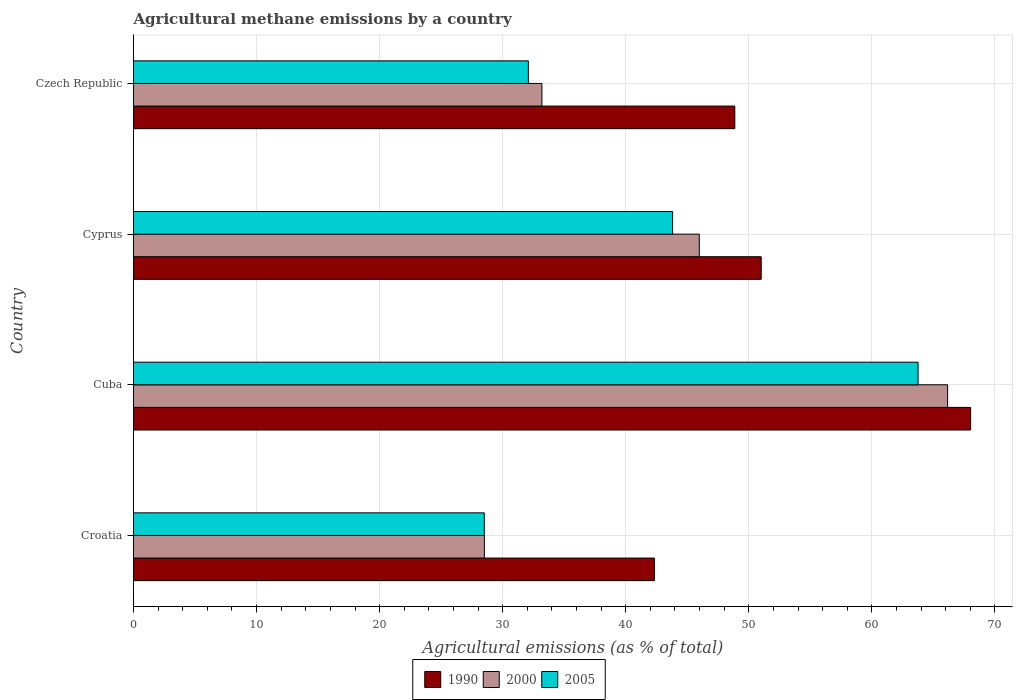How many bars are there on the 4th tick from the bottom?
Offer a very short reply. 3. What is the label of the 1st group of bars from the top?
Ensure brevity in your answer.  Czech Republic. In how many cases, is the number of bars for a given country not equal to the number of legend labels?
Give a very brief answer. 0. What is the amount of agricultural methane emitted in 1990 in Cuba?
Offer a very short reply. 68.03. Across all countries, what is the maximum amount of agricultural methane emitted in 1990?
Provide a short and direct response. 68.03. Across all countries, what is the minimum amount of agricultural methane emitted in 1990?
Ensure brevity in your answer.  42.33. In which country was the amount of agricultural methane emitted in 2000 maximum?
Your answer should be compact. Cuba. In which country was the amount of agricultural methane emitted in 2000 minimum?
Give a very brief answer. Croatia. What is the total amount of agricultural methane emitted in 1990 in the graph?
Provide a succinct answer. 210.22. What is the difference between the amount of agricultural methane emitted in 2005 in Cuba and that in Czech Republic?
Give a very brief answer. 31.67. What is the difference between the amount of agricultural methane emitted in 1990 in Croatia and the amount of agricultural methane emitted in 2005 in Cuba?
Provide a short and direct response. -21.43. What is the average amount of agricultural methane emitted in 2000 per country?
Keep it short and to the point. 43.46. What is the difference between the amount of agricultural methane emitted in 2005 and amount of agricultural methane emitted in 1990 in Croatia?
Offer a terse response. -13.82. In how many countries, is the amount of agricultural methane emitted in 2000 greater than 64 %?
Offer a terse response. 1. What is the ratio of the amount of agricultural methane emitted in 2000 in Cyprus to that in Czech Republic?
Your answer should be compact. 1.39. What is the difference between the highest and the second highest amount of agricultural methane emitted in 2000?
Provide a short and direct response. 20.18. What is the difference between the highest and the lowest amount of agricultural methane emitted in 2005?
Give a very brief answer. 35.25. What does the 3rd bar from the top in Croatia represents?
Your response must be concise. 1990. What does the 2nd bar from the bottom in Cyprus represents?
Your response must be concise. 2000. Is it the case that in every country, the sum of the amount of agricultural methane emitted in 1990 and amount of agricultural methane emitted in 2000 is greater than the amount of agricultural methane emitted in 2005?
Offer a terse response. Yes. How many countries are there in the graph?
Offer a terse response. 4. What is the difference between two consecutive major ticks on the X-axis?
Give a very brief answer. 10. Does the graph contain grids?
Ensure brevity in your answer.  Yes. Where does the legend appear in the graph?
Ensure brevity in your answer.  Bottom center. How are the legend labels stacked?
Offer a terse response. Horizontal. What is the title of the graph?
Offer a terse response. Agricultural methane emissions by a country. Does "2011" appear as one of the legend labels in the graph?
Your answer should be very brief. No. What is the label or title of the X-axis?
Keep it short and to the point. Agricultural emissions (as % of total). What is the Agricultural emissions (as % of total) in 1990 in Croatia?
Make the answer very short. 42.33. What is the Agricultural emissions (as % of total) of 2000 in Croatia?
Offer a terse response. 28.51. What is the Agricultural emissions (as % of total) in 2005 in Croatia?
Make the answer very short. 28.51. What is the Agricultural emissions (as % of total) of 1990 in Cuba?
Ensure brevity in your answer.  68.03. What is the Agricultural emissions (as % of total) in 2000 in Cuba?
Ensure brevity in your answer.  66.16. What is the Agricultural emissions (as % of total) of 2005 in Cuba?
Your response must be concise. 63.76. What is the Agricultural emissions (as % of total) in 1990 in Cyprus?
Provide a succinct answer. 51.01. What is the Agricultural emissions (as % of total) in 2000 in Cyprus?
Provide a short and direct response. 45.98. What is the Agricultural emissions (as % of total) of 2005 in Cyprus?
Your answer should be very brief. 43.81. What is the Agricultural emissions (as % of total) in 1990 in Czech Republic?
Offer a terse response. 48.86. What is the Agricultural emissions (as % of total) in 2000 in Czech Republic?
Provide a succinct answer. 33.19. What is the Agricultural emissions (as % of total) of 2005 in Czech Republic?
Provide a succinct answer. 32.09. Across all countries, what is the maximum Agricultural emissions (as % of total) in 1990?
Your answer should be compact. 68.03. Across all countries, what is the maximum Agricultural emissions (as % of total) of 2000?
Provide a short and direct response. 66.16. Across all countries, what is the maximum Agricultural emissions (as % of total) in 2005?
Keep it short and to the point. 63.76. Across all countries, what is the minimum Agricultural emissions (as % of total) in 1990?
Your response must be concise. 42.33. Across all countries, what is the minimum Agricultural emissions (as % of total) of 2000?
Provide a succinct answer. 28.51. Across all countries, what is the minimum Agricultural emissions (as % of total) in 2005?
Your response must be concise. 28.51. What is the total Agricultural emissions (as % of total) in 1990 in the graph?
Provide a short and direct response. 210.22. What is the total Agricultural emissions (as % of total) of 2000 in the graph?
Offer a very short reply. 173.83. What is the total Agricultural emissions (as % of total) in 2005 in the graph?
Your answer should be very brief. 168.16. What is the difference between the Agricultural emissions (as % of total) in 1990 in Croatia and that in Cuba?
Give a very brief answer. -25.7. What is the difference between the Agricultural emissions (as % of total) of 2000 in Croatia and that in Cuba?
Ensure brevity in your answer.  -37.65. What is the difference between the Agricultural emissions (as % of total) of 2005 in Croatia and that in Cuba?
Provide a succinct answer. -35.25. What is the difference between the Agricultural emissions (as % of total) of 1990 in Croatia and that in Cyprus?
Keep it short and to the point. -8.68. What is the difference between the Agricultural emissions (as % of total) of 2000 in Croatia and that in Cyprus?
Provide a short and direct response. -17.47. What is the difference between the Agricultural emissions (as % of total) in 2005 in Croatia and that in Cyprus?
Provide a short and direct response. -15.3. What is the difference between the Agricultural emissions (as % of total) in 1990 in Croatia and that in Czech Republic?
Your answer should be compact. -6.53. What is the difference between the Agricultural emissions (as % of total) of 2000 in Croatia and that in Czech Republic?
Provide a short and direct response. -4.68. What is the difference between the Agricultural emissions (as % of total) of 2005 in Croatia and that in Czech Republic?
Your answer should be compact. -3.58. What is the difference between the Agricultural emissions (as % of total) in 1990 in Cuba and that in Cyprus?
Your response must be concise. 17.02. What is the difference between the Agricultural emissions (as % of total) in 2000 in Cuba and that in Cyprus?
Keep it short and to the point. 20.18. What is the difference between the Agricultural emissions (as % of total) in 2005 in Cuba and that in Cyprus?
Your answer should be compact. 19.95. What is the difference between the Agricultural emissions (as % of total) of 1990 in Cuba and that in Czech Republic?
Your answer should be compact. 19.16. What is the difference between the Agricultural emissions (as % of total) in 2000 in Cuba and that in Czech Republic?
Offer a terse response. 32.97. What is the difference between the Agricultural emissions (as % of total) of 2005 in Cuba and that in Czech Republic?
Offer a terse response. 31.67. What is the difference between the Agricultural emissions (as % of total) of 1990 in Cyprus and that in Czech Republic?
Give a very brief answer. 2.15. What is the difference between the Agricultural emissions (as % of total) of 2000 in Cyprus and that in Czech Republic?
Offer a very short reply. 12.79. What is the difference between the Agricultural emissions (as % of total) of 2005 in Cyprus and that in Czech Republic?
Keep it short and to the point. 11.72. What is the difference between the Agricultural emissions (as % of total) of 1990 in Croatia and the Agricultural emissions (as % of total) of 2000 in Cuba?
Offer a very short reply. -23.83. What is the difference between the Agricultural emissions (as % of total) in 1990 in Croatia and the Agricultural emissions (as % of total) in 2005 in Cuba?
Keep it short and to the point. -21.43. What is the difference between the Agricultural emissions (as % of total) in 2000 in Croatia and the Agricultural emissions (as % of total) in 2005 in Cuba?
Keep it short and to the point. -35.24. What is the difference between the Agricultural emissions (as % of total) of 1990 in Croatia and the Agricultural emissions (as % of total) of 2000 in Cyprus?
Your response must be concise. -3.65. What is the difference between the Agricultural emissions (as % of total) of 1990 in Croatia and the Agricultural emissions (as % of total) of 2005 in Cyprus?
Make the answer very short. -1.48. What is the difference between the Agricultural emissions (as % of total) of 2000 in Croatia and the Agricultural emissions (as % of total) of 2005 in Cyprus?
Give a very brief answer. -15.3. What is the difference between the Agricultural emissions (as % of total) of 1990 in Croatia and the Agricultural emissions (as % of total) of 2000 in Czech Republic?
Give a very brief answer. 9.14. What is the difference between the Agricultural emissions (as % of total) in 1990 in Croatia and the Agricultural emissions (as % of total) in 2005 in Czech Republic?
Offer a terse response. 10.24. What is the difference between the Agricultural emissions (as % of total) of 2000 in Croatia and the Agricultural emissions (as % of total) of 2005 in Czech Republic?
Ensure brevity in your answer.  -3.58. What is the difference between the Agricultural emissions (as % of total) in 1990 in Cuba and the Agricultural emissions (as % of total) in 2000 in Cyprus?
Offer a terse response. 22.05. What is the difference between the Agricultural emissions (as % of total) of 1990 in Cuba and the Agricultural emissions (as % of total) of 2005 in Cyprus?
Offer a very short reply. 24.22. What is the difference between the Agricultural emissions (as % of total) in 2000 in Cuba and the Agricultural emissions (as % of total) in 2005 in Cyprus?
Make the answer very short. 22.35. What is the difference between the Agricultural emissions (as % of total) of 1990 in Cuba and the Agricultural emissions (as % of total) of 2000 in Czech Republic?
Your response must be concise. 34.84. What is the difference between the Agricultural emissions (as % of total) in 1990 in Cuba and the Agricultural emissions (as % of total) in 2005 in Czech Republic?
Ensure brevity in your answer.  35.94. What is the difference between the Agricultural emissions (as % of total) in 2000 in Cuba and the Agricultural emissions (as % of total) in 2005 in Czech Republic?
Offer a very short reply. 34.07. What is the difference between the Agricultural emissions (as % of total) of 1990 in Cyprus and the Agricultural emissions (as % of total) of 2000 in Czech Republic?
Keep it short and to the point. 17.82. What is the difference between the Agricultural emissions (as % of total) of 1990 in Cyprus and the Agricultural emissions (as % of total) of 2005 in Czech Republic?
Provide a succinct answer. 18.92. What is the difference between the Agricultural emissions (as % of total) in 2000 in Cyprus and the Agricultural emissions (as % of total) in 2005 in Czech Republic?
Ensure brevity in your answer.  13.89. What is the average Agricultural emissions (as % of total) in 1990 per country?
Your answer should be compact. 52.56. What is the average Agricultural emissions (as % of total) in 2000 per country?
Give a very brief answer. 43.46. What is the average Agricultural emissions (as % of total) of 2005 per country?
Provide a short and direct response. 42.04. What is the difference between the Agricultural emissions (as % of total) in 1990 and Agricultural emissions (as % of total) in 2000 in Croatia?
Your answer should be very brief. 13.82. What is the difference between the Agricultural emissions (as % of total) in 1990 and Agricultural emissions (as % of total) in 2005 in Croatia?
Make the answer very short. 13.82. What is the difference between the Agricultural emissions (as % of total) in 2000 and Agricultural emissions (as % of total) in 2005 in Croatia?
Your answer should be very brief. 0. What is the difference between the Agricultural emissions (as % of total) in 1990 and Agricultural emissions (as % of total) in 2000 in Cuba?
Your answer should be compact. 1.87. What is the difference between the Agricultural emissions (as % of total) in 1990 and Agricultural emissions (as % of total) in 2005 in Cuba?
Offer a very short reply. 4.27. What is the difference between the Agricultural emissions (as % of total) of 2000 and Agricultural emissions (as % of total) of 2005 in Cuba?
Give a very brief answer. 2.4. What is the difference between the Agricultural emissions (as % of total) of 1990 and Agricultural emissions (as % of total) of 2000 in Cyprus?
Provide a short and direct response. 5.03. What is the difference between the Agricultural emissions (as % of total) of 1990 and Agricultural emissions (as % of total) of 2005 in Cyprus?
Ensure brevity in your answer.  7.2. What is the difference between the Agricultural emissions (as % of total) of 2000 and Agricultural emissions (as % of total) of 2005 in Cyprus?
Keep it short and to the point. 2.17. What is the difference between the Agricultural emissions (as % of total) in 1990 and Agricultural emissions (as % of total) in 2000 in Czech Republic?
Give a very brief answer. 15.67. What is the difference between the Agricultural emissions (as % of total) in 1990 and Agricultural emissions (as % of total) in 2005 in Czech Republic?
Make the answer very short. 16.78. What is the difference between the Agricultural emissions (as % of total) in 2000 and Agricultural emissions (as % of total) in 2005 in Czech Republic?
Ensure brevity in your answer.  1.1. What is the ratio of the Agricultural emissions (as % of total) in 1990 in Croatia to that in Cuba?
Make the answer very short. 0.62. What is the ratio of the Agricultural emissions (as % of total) in 2000 in Croatia to that in Cuba?
Make the answer very short. 0.43. What is the ratio of the Agricultural emissions (as % of total) in 2005 in Croatia to that in Cuba?
Your answer should be compact. 0.45. What is the ratio of the Agricultural emissions (as % of total) in 1990 in Croatia to that in Cyprus?
Ensure brevity in your answer.  0.83. What is the ratio of the Agricultural emissions (as % of total) of 2000 in Croatia to that in Cyprus?
Your answer should be very brief. 0.62. What is the ratio of the Agricultural emissions (as % of total) in 2005 in Croatia to that in Cyprus?
Ensure brevity in your answer.  0.65. What is the ratio of the Agricultural emissions (as % of total) of 1990 in Croatia to that in Czech Republic?
Offer a very short reply. 0.87. What is the ratio of the Agricultural emissions (as % of total) of 2000 in Croatia to that in Czech Republic?
Offer a very short reply. 0.86. What is the ratio of the Agricultural emissions (as % of total) in 2005 in Croatia to that in Czech Republic?
Provide a succinct answer. 0.89. What is the ratio of the Agricultural emissions (as % of total) in 1990 in Cuba to that in Cyprus?
Your answer should be compact. 1.33. What is the ratio of the Agricultural emissions (as % of total) of 2000 in Cuba to that in Cyprus?
Provide a succinct answer. 1.44. What is the ratio of the Agricultural emissions (as % of total) of 2005 in Cuba to that in Cyprus?
Your answer should be compact. 1.46. What is the ratio of the Agricultural emissions (as % of total) of 1990 in Cuba to that in Czech Republic?
Offer a very short reply. 1.39. What is the ratio of the Agricultural emissions (as % of total) in 2000 in Cuba to that in Czech Republic?
Offer a terse response. 1.99. What is the ratio of the Agricultural emissions (as % of total) of 2005 in Cuba to that in Czech Republic?
Offer a terse response. 1.99. What is the ratio of the Agricultural emissions (as % of total) of 1990 in Cyprus to that in Czech Republic?
Your response must be concise. 1.04. What is the ratio of the Agricultural emissions (as % of total) of 2000 in Cyprus to that in Czech Republic?
Your answer should be very brief. 1.39. What is the ratio of the Agricultural emissions (as % of total) in 2005 in Cyprus to that in Czech Republic?
Ensure brevity in your answer.  1.37. What is the difference between the highest and the second highest Agricultural emissions (as % of total) in 1990?
Your response must be concise. 17.02. What is the difference between the highest and the second highest Agricultural emissions (as % of total) in 2000?
Your response must be concise. 20.18. What is the difference between the highest and the second highest Agricultural emissions (as % of total) of 2005?
Make the answer very short. 19.95. What is the difference between the highest and the lowest Agricultural emissions (as % of total) in 1990?
Give a very brief answer. 25.7. What is the difference between the highest and the lowest Agricultural emissions (as % of total) of 2000?
Your answer should be very brief. 37.65. What is the difference between the highest and the lowest Agricultural emissions (as % of total) of 2005?
Give a very brief answer. 35.25. 